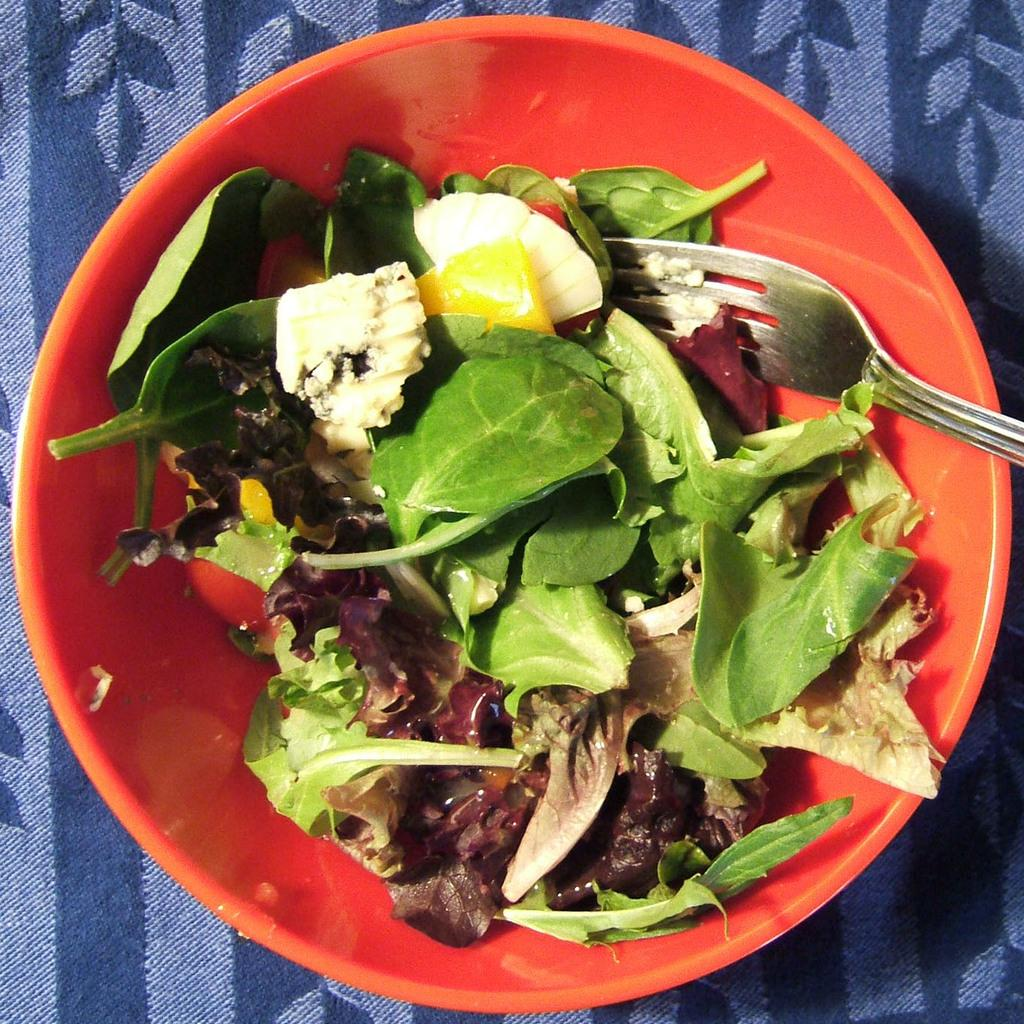What is present in the image that people typically eat? There is food in the image. What utensil is used with the food in the image? There is a fork in the bowl. What can be seen on the table in the background of the image? There is a cloth on the table in the background. What type of insurance is being discussed in the image? There is no discussion of insurance in the image; it features food, a fork, and a cloth on the table. 